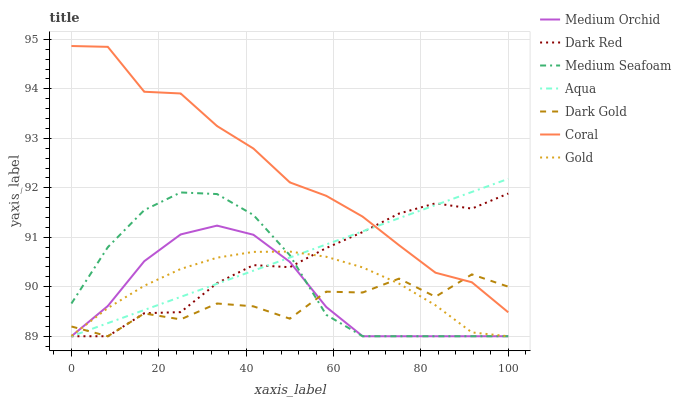Does Dark Red have the minimum area under the curve?
Answer yes or no. No. Does Dark Red have the maximum area under the curve?
Answer yes or no. No. Is Dark Red the smoothest?
Answer yes or no. No. Is Dark Red the roughest?
Answer yes or no. No. Does Coral have the lowest value?
Answer yes or no. No. Does Dark Red have the highest value?
Answer yes or no. No. Is Medium Orchid less than Coral?
Answer yes or no. Yes. Is Coral greater than Medium Seafoam?
Answer yes or no. Yes. Does Medium Orchid intersect Coral?
Answer yes or no. No. 